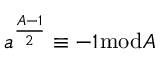<formula> <loc_0><loc_0><loc_500><loc_500>a ^ { \frac { A - 1 } { 2 } } \equiv - 1 { \bmod { A } }</formula> 